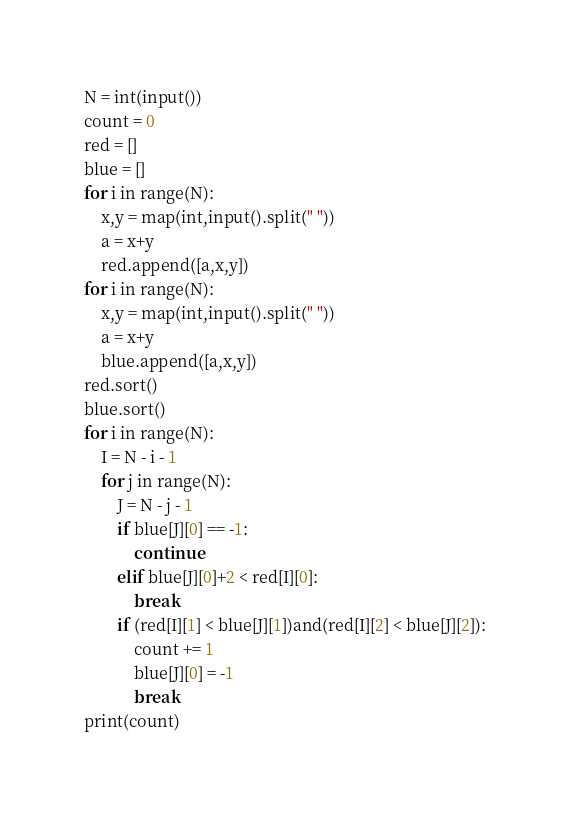Convert code to text. <code><loc_0><loc_0><loc_500><loc_500><_Python_>N = int(input())
count = 0
red = []
blue = []
for i in range(N):
    x,y = map(int,input().split(" "))
    a = x+y
    red.append([a,x,y])
for i in range(N):
    x,y = map(int,input().split(" "))
    a = x+y
    blue.append([a,x,y])
red.sort()
blue.sort()
for i in range(N):
    I = N - i - 1
    for j in range(N):
        J = N - j - 1
        if blue[J][0] == -1:
            continue
        elif blue[J][0]+2 < red[I][0]:
            break
        if (red[I][1] < blue[J][1])and(red[I][2] < blue[J][2]):
            count += 1
            blue[J][0] = -1
            break
print(count)
</code> 